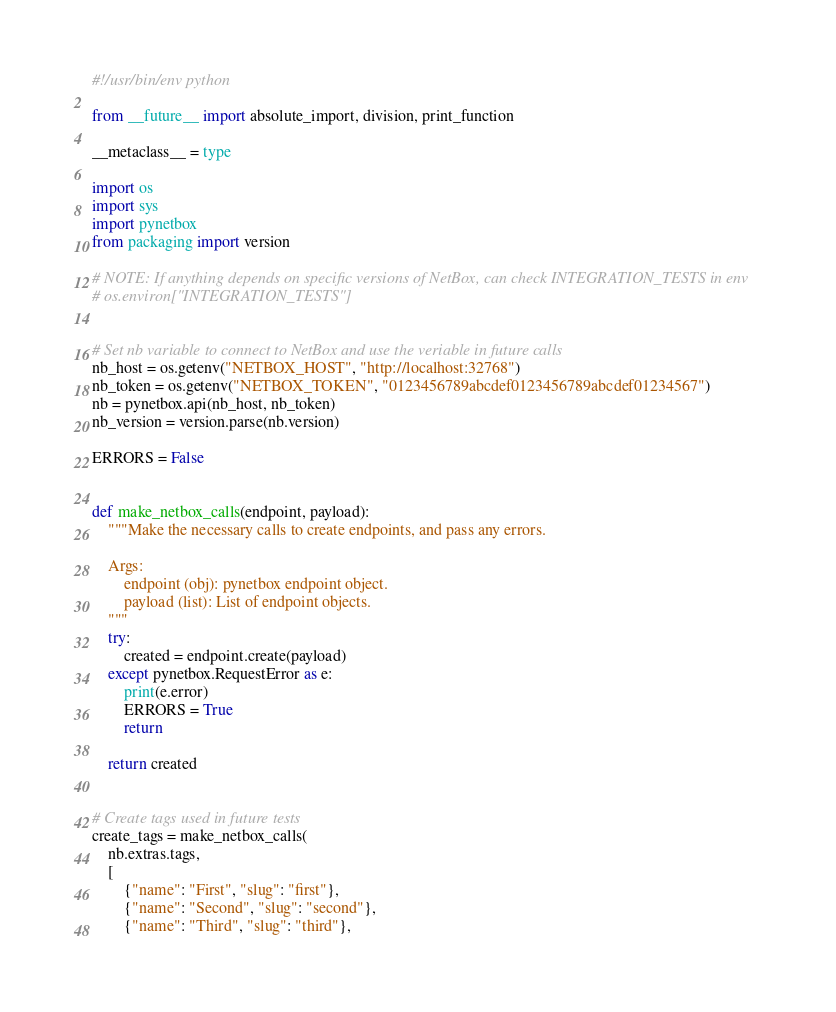Convert code to text. <code><loc_0><loc_0><loc_500><loc_500><_Python_>#!/usr/bin/env python

from __future__ import absolute_import, division, print_function

__metaclass__ = type

import os
import sys
import pynetbox
from packaging import version

# NOTE: If anything depends on specific versions of NetBox, can check INTEGRATION_TESTS in env
# os.environ["INTEGRATION_TESTS"]


# Set nb variable to connect to NetBox and use the veriable in future calls
nb_host = os.getenv("NETBOX_HOST", "http://localhost:32768")
nb_token = os.getenv("NETBOX_TOKEN", "0123456789abcdef0123456789abcdef01234567")
nb = pynetbox.api(nb_host, nb_token)
nb_version = version.parse(nb.version)

ERRORS = False


def make_netbox_calls(endpoint, payload):
    """Make the necessary calls to create endpoints, and pass any errors.

    Args:
        endpoint (obj): pynetbox endpoint object.
        payload (list): List of endpoint objects.
    """
    try:
        created = endpoint.create(payload)
    except pynetbox.RequestError as e:
        print(e.error)
        ERRORS = True
        return

    return created


# Create tags used in future tests
create_tags = make_netbox_calls(
    nb.extras.tags,
    [
        {"name": "First", "slug": "first"},
        {"name": "Second", "slug": "second"},
        {"name": "Third", "slug": "third"},</code> 